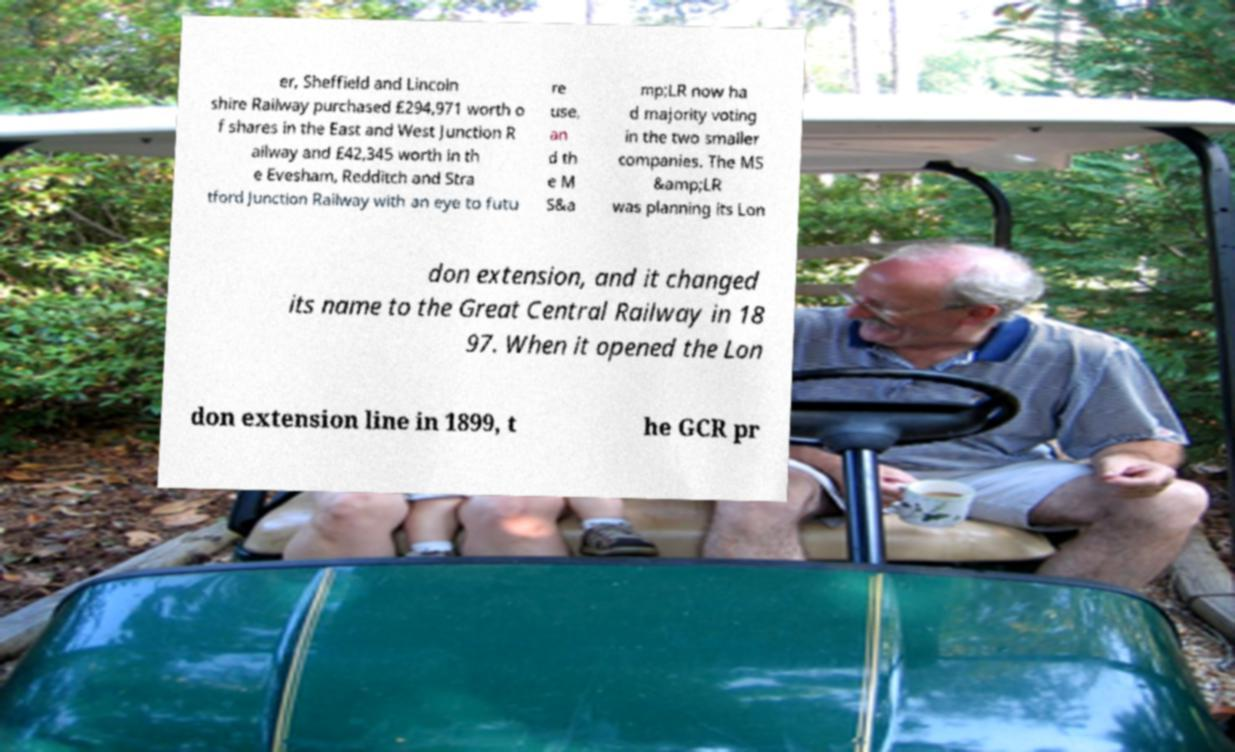I need the written content from this picture converted into text. Can you do that? er, Sheffield and Lincoln shire Railway purchased £294,971 worth o f shares in the East and West Junction R ailway and £42,345 worth in th e Evesham, Redditch and Stra tford Junction Railway with an eye to futu re use, an d th e M S&a mp;LR now ha d majority voting in the two smaller companies. The MS &amp;LR was planning its Lon don extension, and it changed its name to the Great Central Railway in 18 97. When it opened the Lon don extension line in 1899, t he GCR pr 